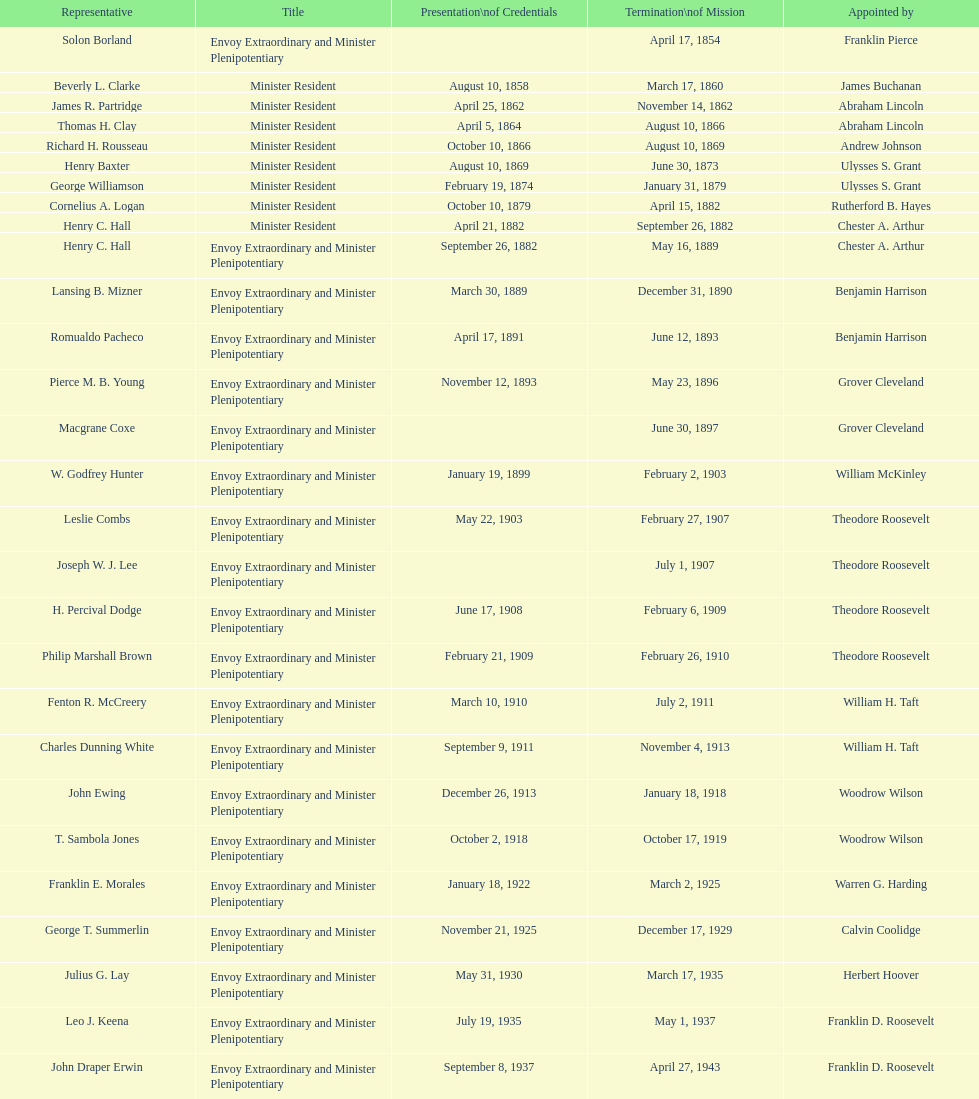Which date comes before april 17, 1854? March 17, 1860. 